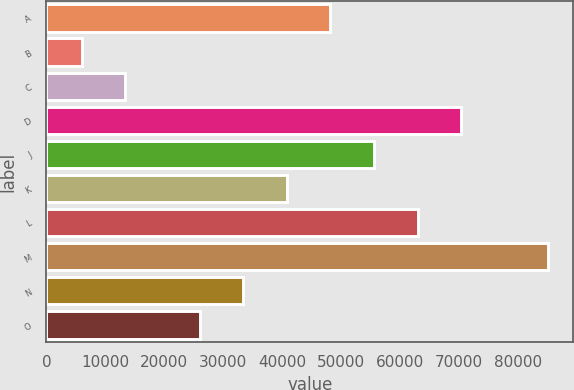Convert chart to OTSL. <chart><loc_0><loc_0><loc_500><loc_500><bar_chart><fcel>A<fcel>B<fcel>C<fcel>D<fcel>J<fcel>K<fcel>L<fcel>M<fcel>N<fcel>O<nl><fcel>48200<fcel>6000<fcel>13400<fcel>70400<fcel>55600<fcel>40800<fcel>63000<fcel>85200<fcel>33400<fcel>26000<nl></chart> 